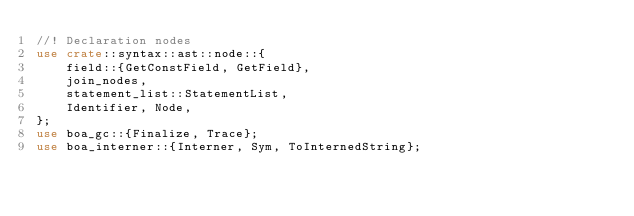Convert code to text. <code><loc_0><loc_0><loc_500><loc_500><_Rust_>//! Declaration nodes
use crate::syntax::ast::node::{
    field::{GetConstField, GetField},
    join_nodes,
    statement_list::StatementList,
    Identifier, Node,
};
use boa_gc::{Finalize, Trace};
use boa_interner::{Interner, Sym, ToInternedString};
</code> 